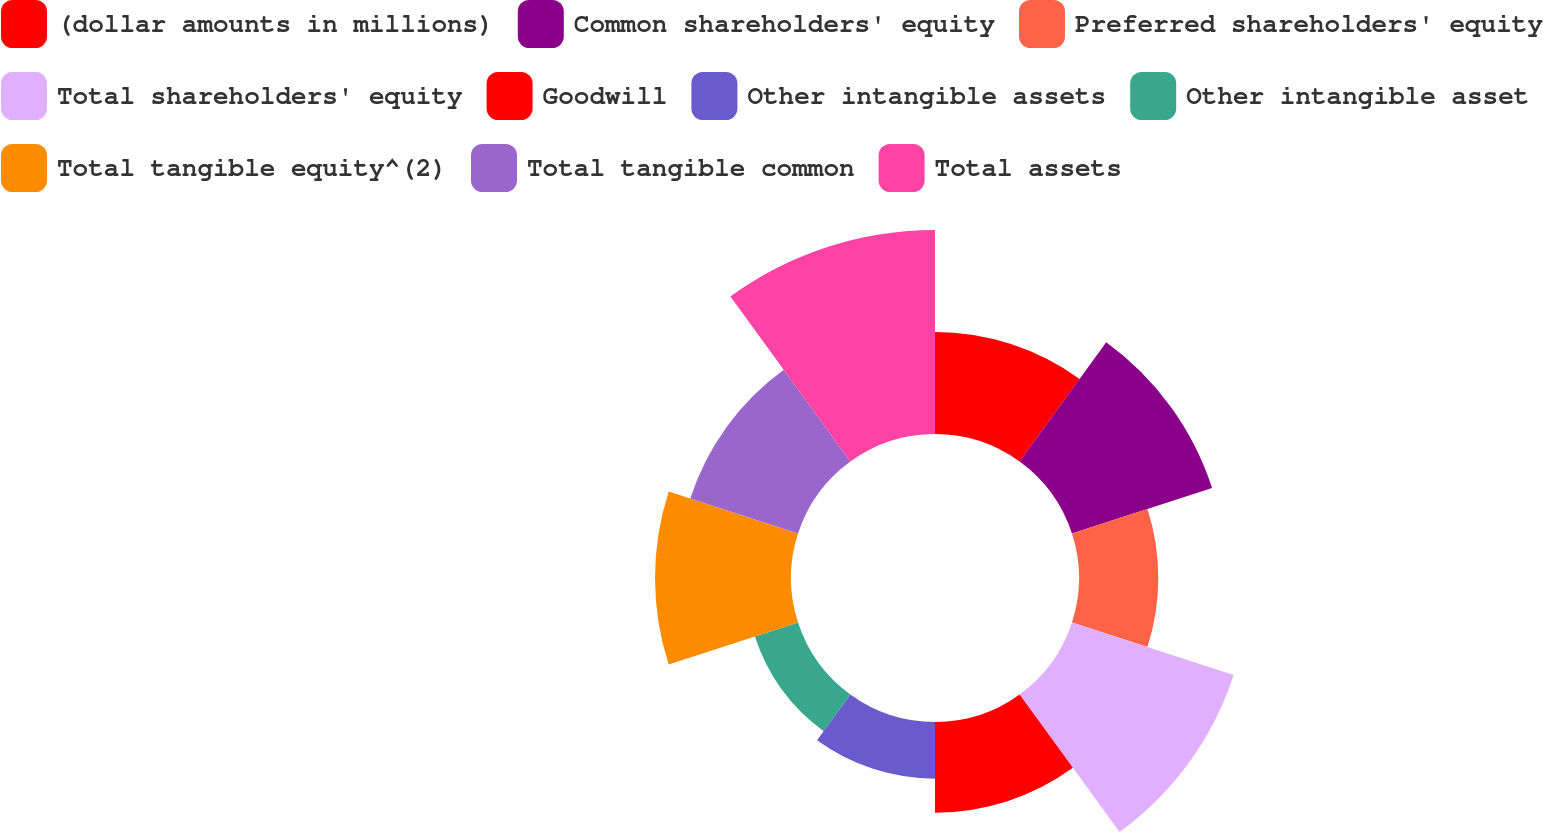<chart> <loc_0><loc_0><loc_500><loc_500><pie_chart><fcel>(dollar amounts in millions)<fcel>Common shareholders' equity<fcel>Preferred shareholders' equity<fcel>Total shareholders' equity<fcel>Goodwill<fcel>Other intangible assets<fcel>Other intangible asset<fcel>Total tangible equity^(2)<fcel>Total tangible common<fcel>Total assets<nl><fcel>8.91%<fcel>12.87%<fcel>6.93%<fcel>14.85%<fcel>7.92%<fcel>4.95%<fcel>3.96%<fcel>11.88%<fcel>9.9%<fcel>17.82%<nl></chart> 